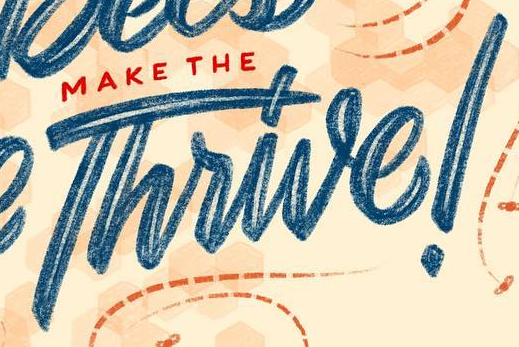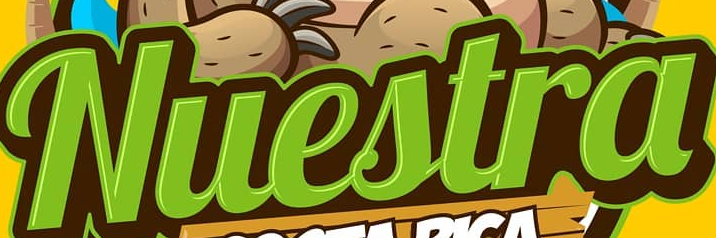What words can you see in these images in sequence, separated by a semicolon? Thrive!; Nuestra 